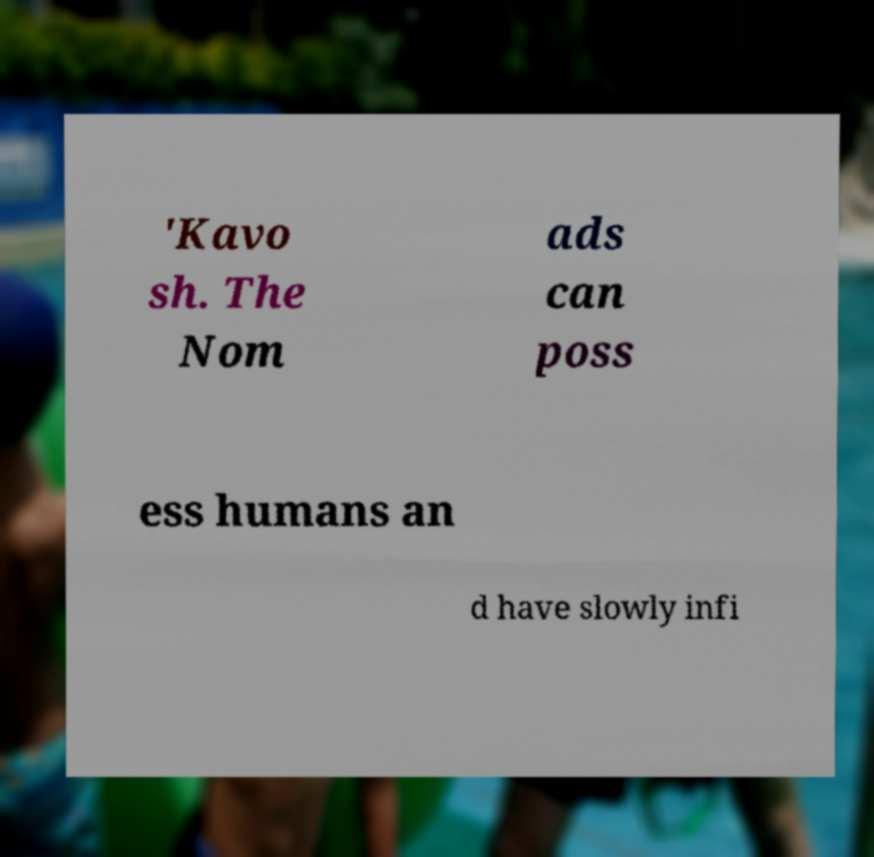There's text embedded in this image that I need extracted. Can you transcribe it verbatim? 'Kavo sh. The Nom ads can poss ess humans an d have slowly infi 